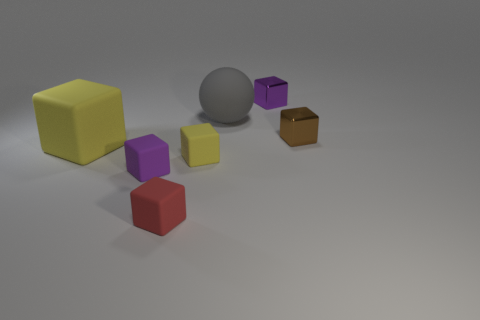Subtract all tiny brown blocks. How many blocks are left? 5 Subtract all brown blocks. How many blocks are left? 5 Subtract all blue blocks. Subtract all gray cylinders. How many blocks are left? 6 Add 3 tiny spheres. How many objects exist? 10 Subtract all blocks. How many objects are left? 1 Subtract all purple metal objects. Subtract all small yellow objects. How many objects are left? 5 Add 7 big gray matte objects. How many big gray matte objects are left? 8 Add 5 purple rubber things. How many purple rubber things exist? 6 Subtract 0 cyan cylinders. How many objects are left? 7 